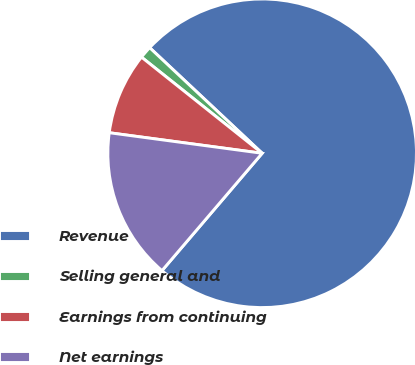Convert chart to OTSL. <chart><loc_0><loc_0><loc_500><loc_500><pie_chart><fcel>Revenue<fcel>Selling general and<fcel>Earnings from continuing<fcel>Net earnings<nl><fcel>74.25%<fcel>1.29%<fcel>8.58%<fcel>15.88%<nl></chart> 